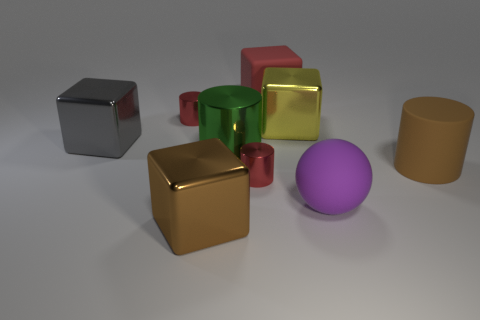Is there a small metal cylinder of the same color as the big matte block?
Offer a terse response. Yes. What shape is the object that is the same color as the matte cylinder?
Give a very brief answer. Cube. The gray object that is the same size as the brown cube is what shape?
Keep it short and to the point. Cube. The cylinder on the right side of the tiny red shiny thing right of the large brown thing that is left of the large brown matte cylinder is what color?
Keep it short and to the point. Brown. Does the red matte thing have the same shape as the large green shiny thing?
Offer a terse response. No. Are there the same number of brown things right of the green thing and tiny cylinders?
Your answer should be very brief. No. What number of other things are made of the same material as the yellow block?
Your answer should be very brief. 5. Do the cylinder that is right of the red rubber object and the cube that is in front of the purple matte thing have the same size?
Your answer should be compact. Yes. What number of things are metal cubes that are on the right side of the large red object or matte objects on the right side of the big red matte object?
Make the answer very short. 3. Is there any other thing that is the same shape as the purple object?
Give a very brief answer. No. 